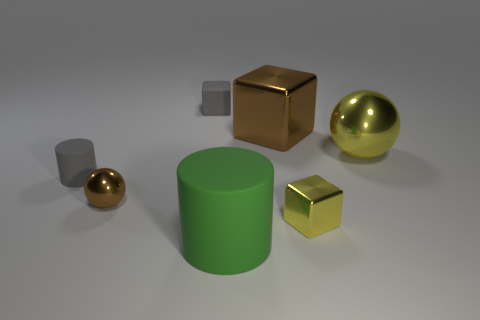There is a small object behind the big yellow metallic ball; what color is it?
Offer a very short reply. Gray. There is a tiny thing that is behind the big thing right of the metallic object behind the big shiny sphere; what is its material?
Offer a very short reply. Rubber. How big is the object that is in front of the yellow object in front of the brown shiny ball?
Your answer should be very brief. Large. What is the color of the other tiny rubber object that is the same shape as the green matte thing?
Offer a terse response. Gray. How many tiny matte objects are the same color as the small cylinder?
Provide a succinct answer. 1. Do the matte block and the yellow block have the same size?
Keep it short and to the point. Yes. What is the small cylinder made of?
Your response must be concise. Rubber. The cube that is the same material as the green thing is what color?
Your answer should be compact. Gray. Do the large cylinder and the brown thing to the right of the big rubber thing have the same material?
Make the answer very short. No. What number of gray cubes are the same material as the small brown ball?
Your answer should be very brief. 0. 